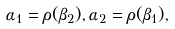<formula> <loc_0><loc_0><loc_500><loc_500>\alpha _ { 1 } = \rho ( \beta _ { 2 } ) , \alpha _ { 2 } = \rho ( \beta _ { 1 } ) ,</formula> 